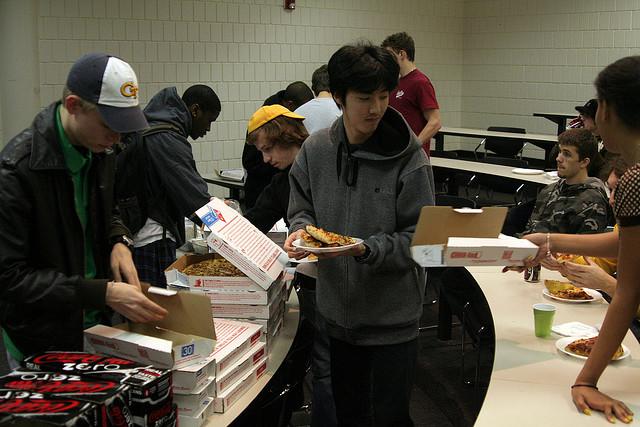Are the pizza for sale?
Be succinct. No. Is there a woman in the picture?
Concise answer only. No. What are they eating?
Quick response, please. Pizza. What kind of room is this?
Concise answer only. Classroom. When do you usually buy the items in the box?
Keep it brief. When hungry. 